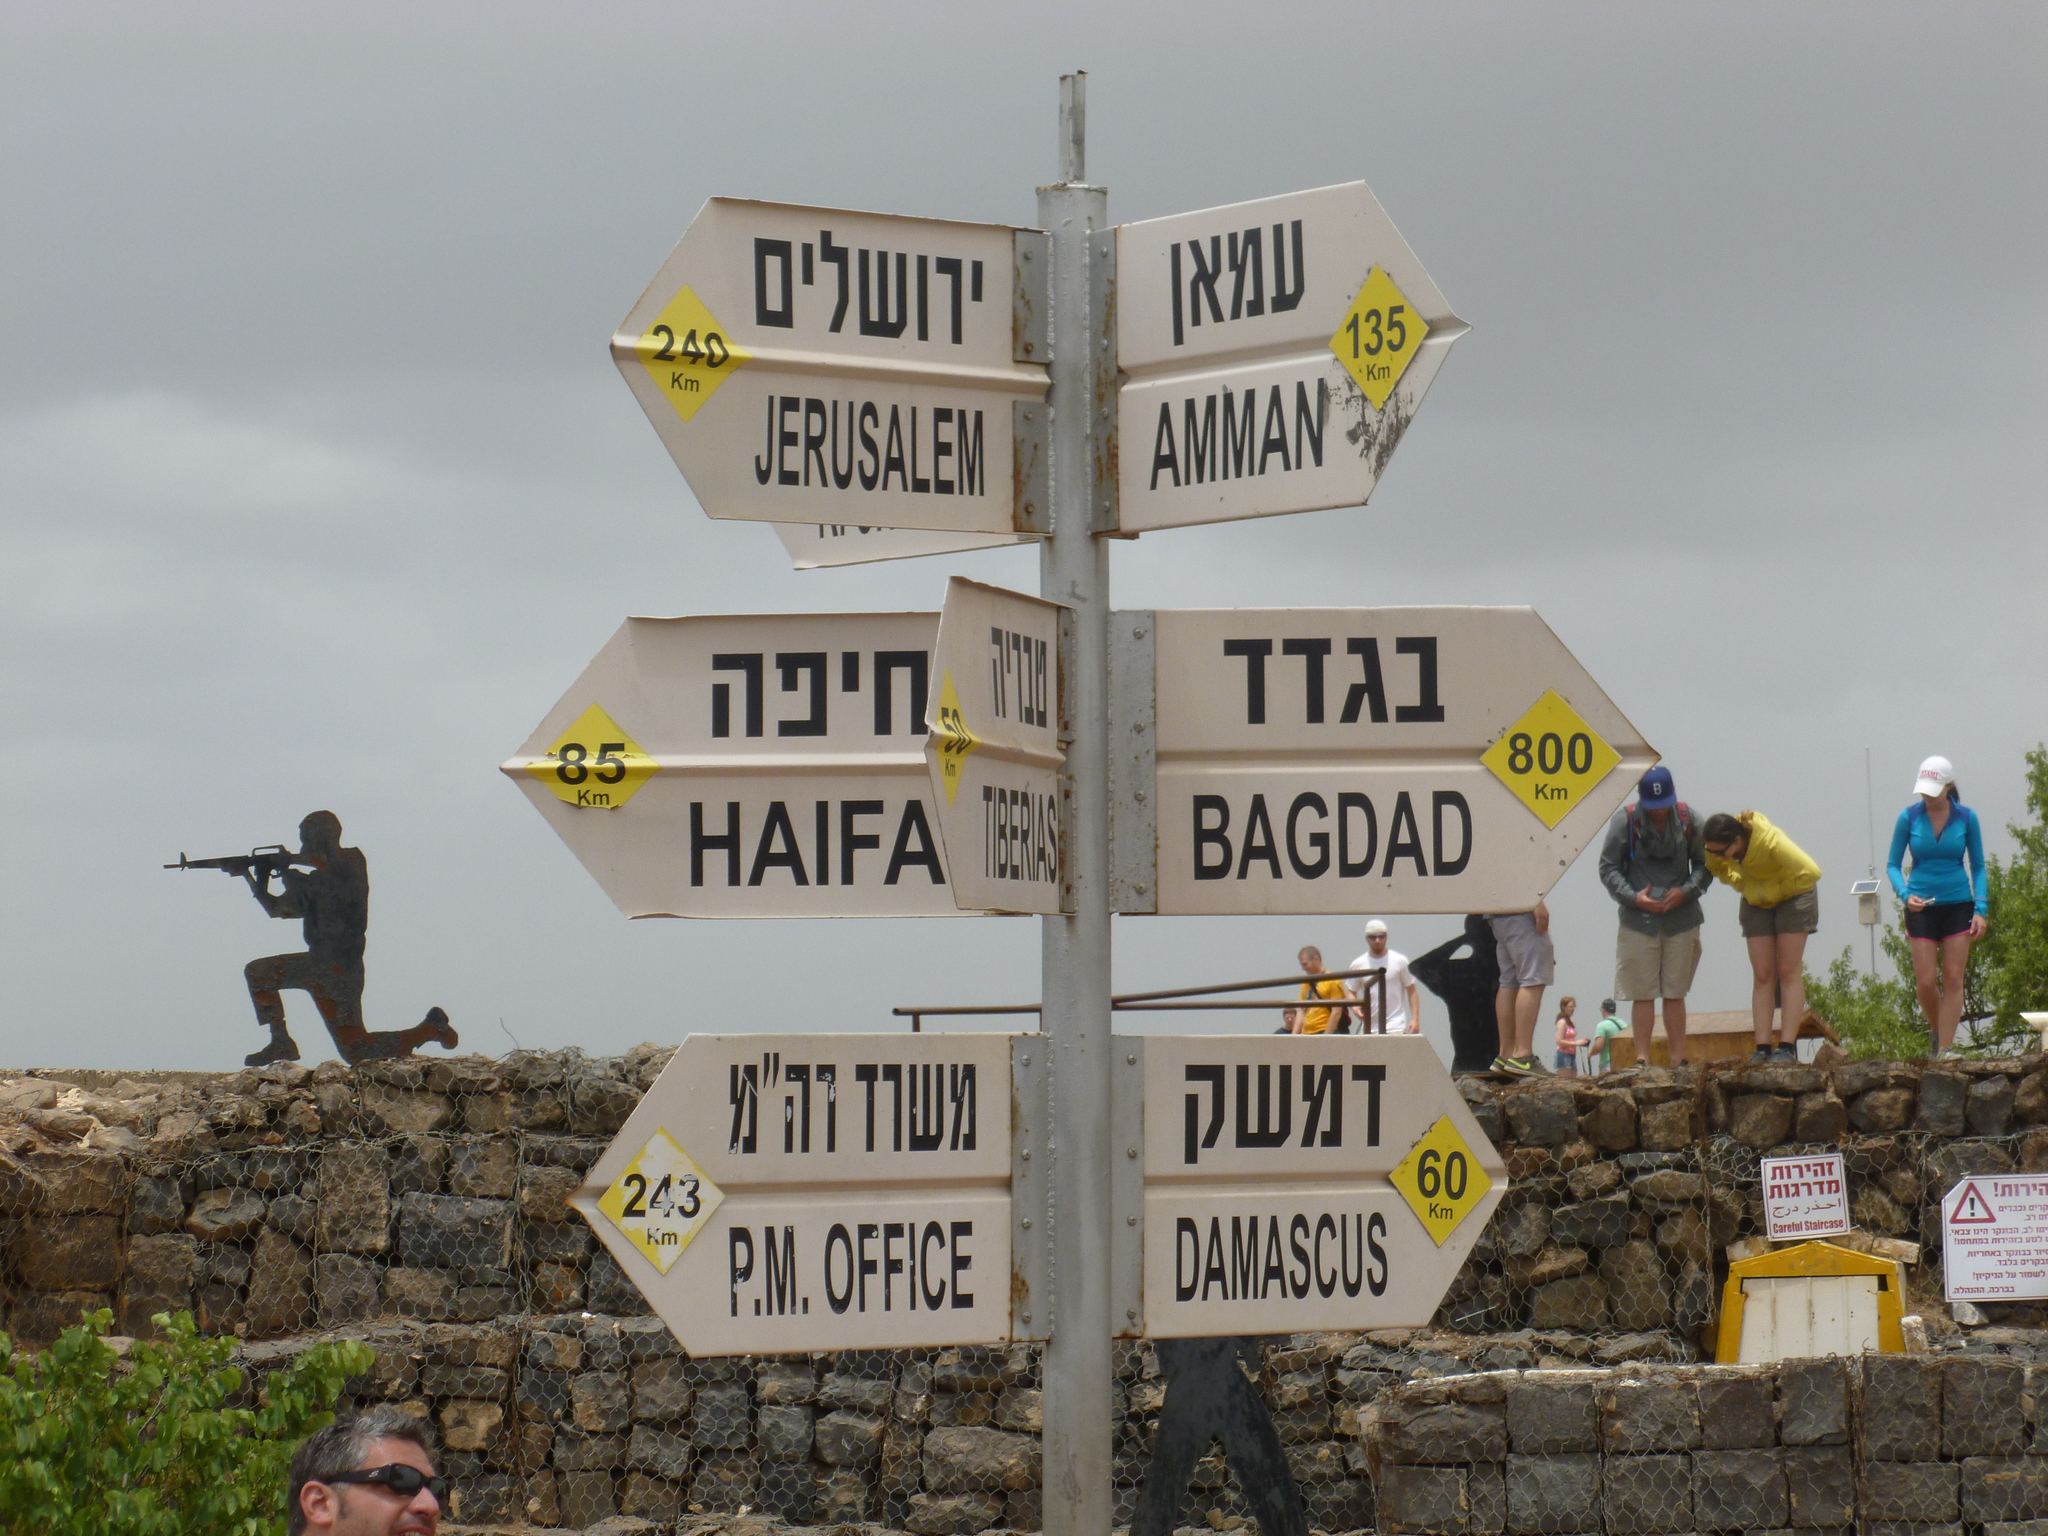<image>
Render a clear and concise summary of the photo. many signs, one of which says bagdad on it 